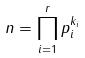Convert formula to latex. <formula><loc_0><loc_0><loc_500><loc_500>n = \prod _ { i = 1 } ^ { r } p _ { i } ^ { k _ { i } }</formula> 